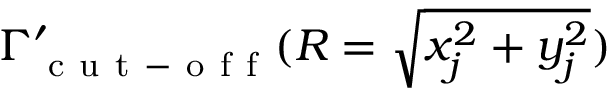Convert formula to latex. <formula><loc_0><loc_0><loc_500><loc_500>\Gamma _ { c u t - o f f } ^ { \prime } ( R = \sqrt { x _ { j } ^ { 2 } + y _ { j } ^ { 2 } } )</formula> 